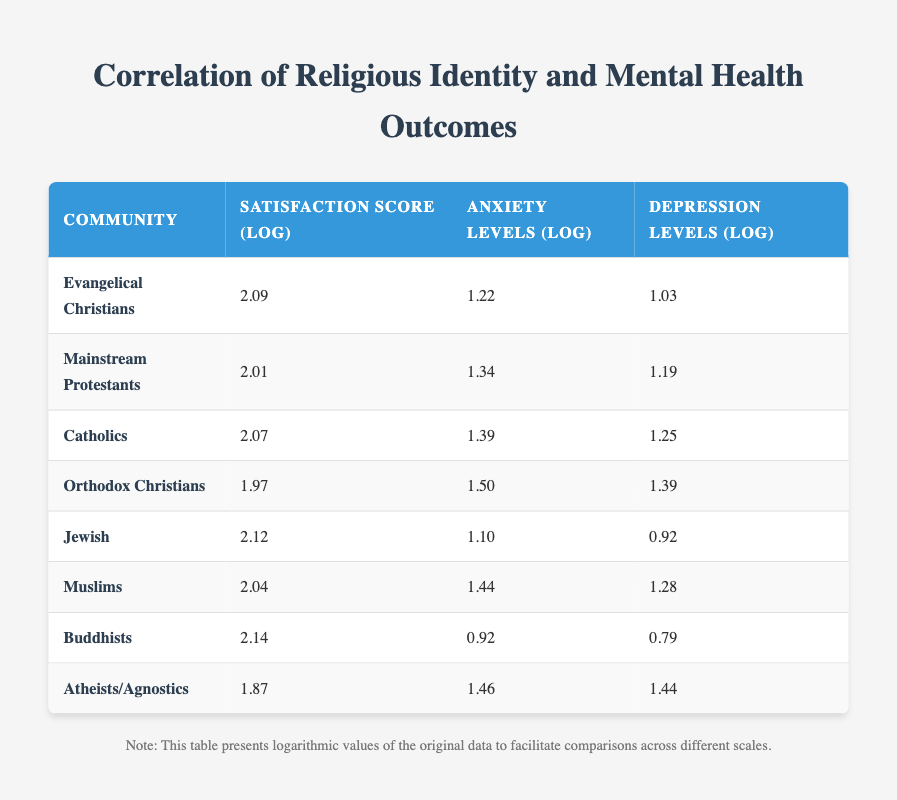What is the average satisfaction score for Buddhists? The table shows that the average satisfaction score for Buddhists is 8.5.
Answer: 8.5 Which community has the highest average anxiety levels? In the table, Orthodox Christians have the highest average anxiety levels at 4.5.
Answer: Orthodox Christians What is the difference in average satisfaction scores between Evangelical Christians and Atheists/Agnostics? The average satisfaction score for Evangelical Christians is 8.1 and for Atheists/Agnostics it is 6.5. The difference is 8.1 - 6.5 = 1.6.
Answer: 1.6 Are Muslims generally more satisfied than Orthodox Christians based on the table? The average satisfaction score for Muslims is 7.7, while for Orthodox Christians it is 7.2. Since 7.7 is greater than 7.2, Muslims are more satisfied.
Answer: Yes What is the sum of average depression levels for Jews and Buddhists? The average depression level for Jews is 2.5 and for Buddhists, it is 2.2. Summing these values gives 2.5 + 2.2 = 4.7.
Answer: 4.7 Which community has the lowest average depression levels? According to the table, Buddhists have the lowest average depression levels at 2.2.
Answer: Buddhists What is the average anxiety level of the three communities with the highest satisfaction scores? The highest satisfaction scores belong to Buddhists (8.5), Jews (8.3), and Evangelical Christians (8.1). Their anxiety levels are 2.5, 3.0, and 3.4 respectively. The sum of these levels is 2.5 + 3.0 + 3.4 = 8.9, and the average is 8.9 / 3 = 2.97.
Answer: 2.97 Do Catholic communities have lower average satisfaction scores compared to Mainstream Protestants? Catholics have an average satisfaction score of 7.9, while Mainstream Protestants have an average of 7.5. Since 7.9 is greater than 7.5, it indicates that Catholics have higher satisfaction.
Answer: No 